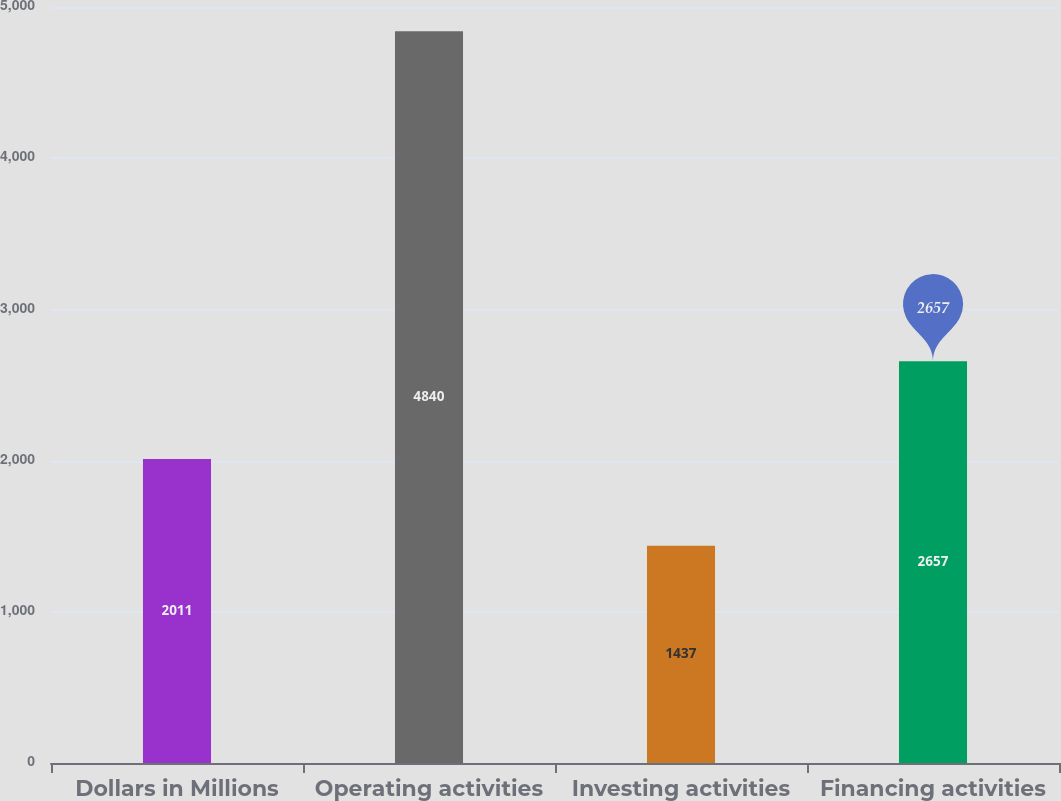Convert chart to OTSL. <chart><loc_0><loc_0><loc_500><loc_500><bar_chart><fcel>Dollars in Millions<fcel>Operating activities<fcel>Investing activities<fcel>Financing activities<nl><fcel>2011<fcel>4840<fcel>1437<fcel>2657<nl></chart> 